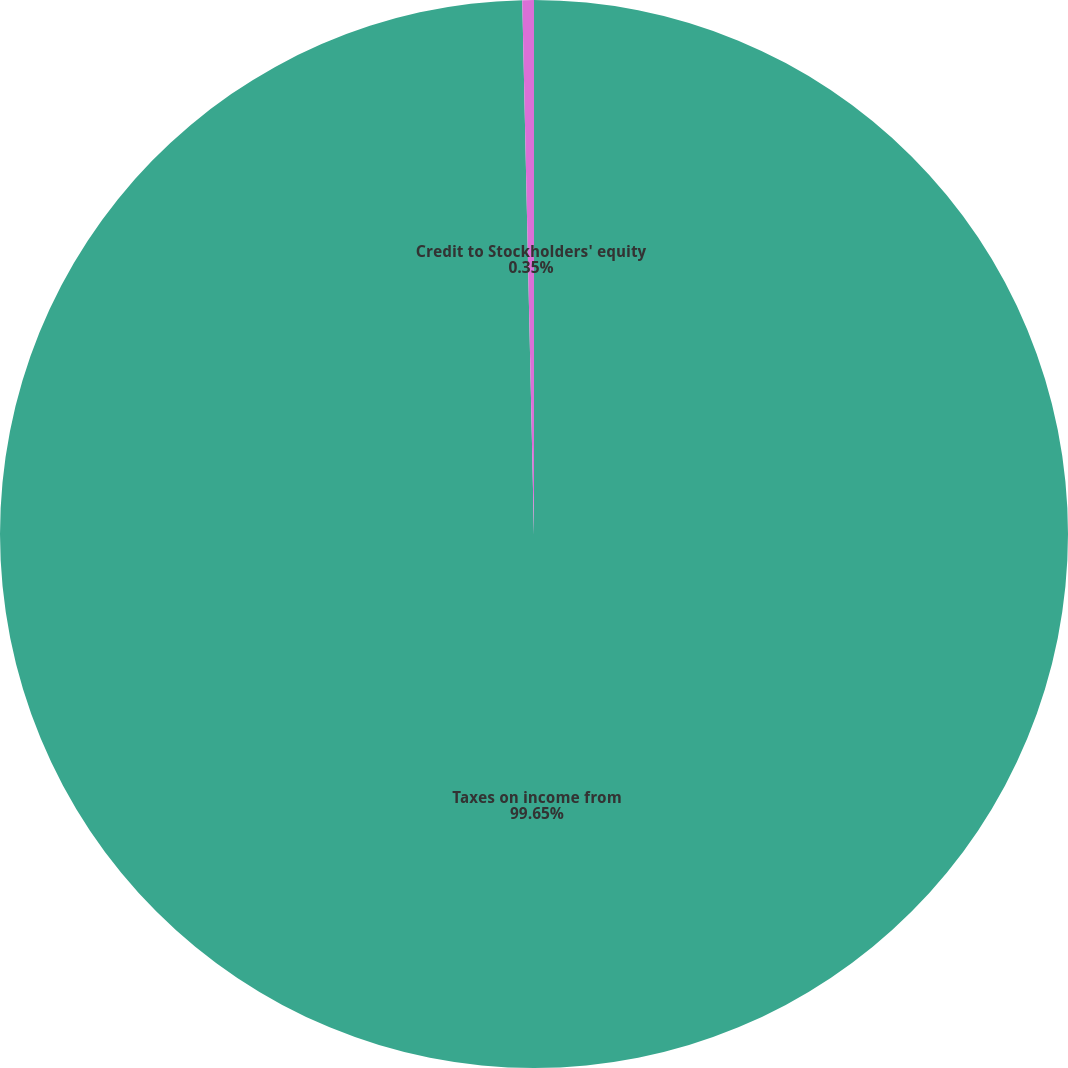Convert chart. <chart><loc_0><loc_0><loc_500><loc_500><pie_chart><fcel>Taxes on income from<fcel>Credit to Stockholders' equity<nl><fcel>99.65%<fcel>0.35%<nl></chart> 